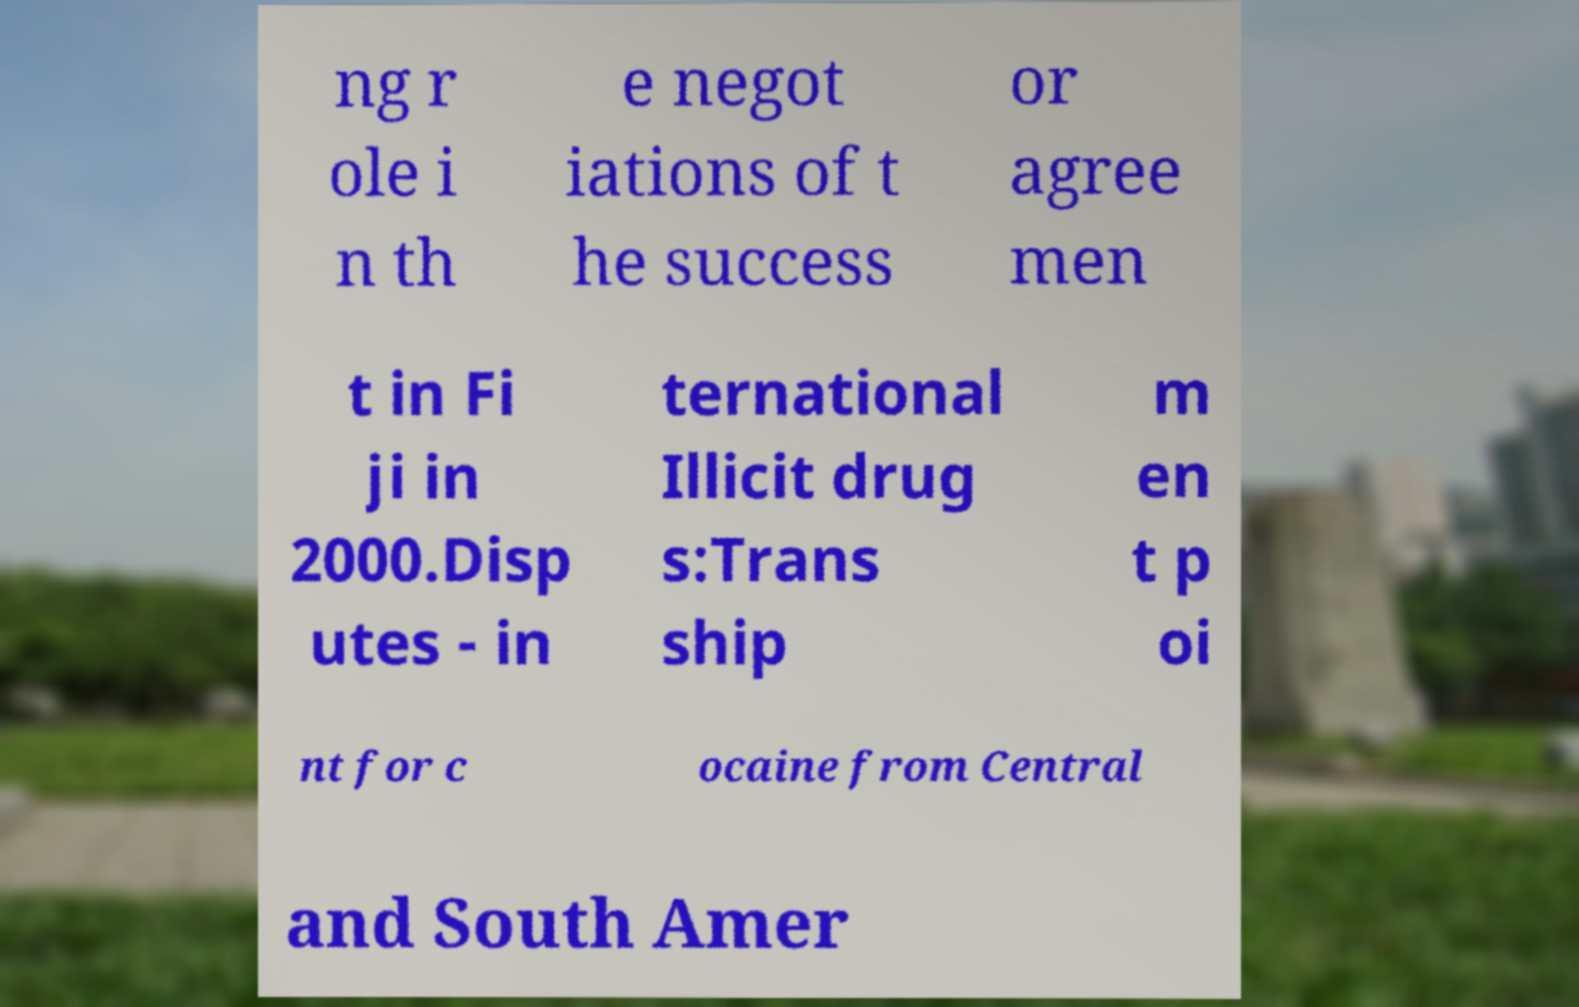Could you extract and type out the text from this image? ng r ole i n th e negot iations of t he success or agree men t in Fi ji in 2000.Disp utes - in ternational Illicit drug s:Trans ship m en t p oi nt for c ocaine from Central and South Amer 